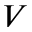<formula> <loc_0><loc_0><loc_500><loc_500>V</formula> 